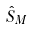Convert formula to latex. <formula><loc_0><loc_0><loc_500><loc_500>\hat { S } _ { M }</formula> 